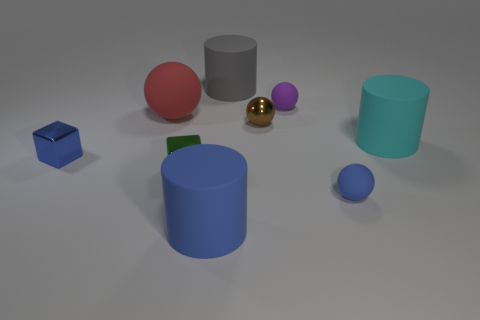There is a large object that is the same shape as the small brown thing; what color is it?
Provide a succinct answer. Red. What is the size of the blue thing that is the same shape as the red object?
Give a very brief answer. Small. What number of metallic objects have the same color as the metallic ball?
Offer a very short reply. 0. Do the big blue rubber thing and the red rubber thing have the same shape?
Ensure brevity in your answer.  No. What size is the ball in front of the shiny block on the left side of the green cube?
Provide a short and direct response. Small. Is there a metallic object of the same size as the gray rubber object?
Your response must be concise. No. Does the rubber cylinder that is in front of the small green object have the same size as the shiny thing behind the small blue shiny cube?
Give a very brief answer. No. The tiny blue thing that is to the left of the tiny thing on the right side of the purple rubber thing is what shape?
Your answer should be compact. Cube. There is a small blue rubber sphere; how many cyan cylinders are to the left of it?
Ensure brevity in your answer.  0. What is the color of the small cube that is the same material as the small green thing?
Your response must be concise. Blue. 